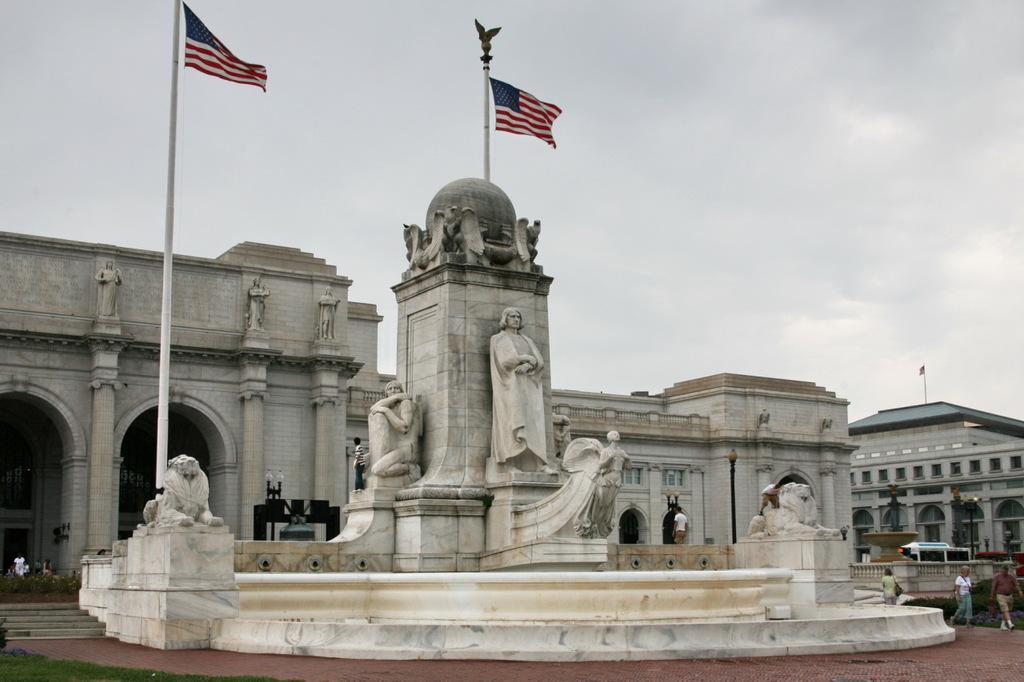In one or two sentences, can you explain what this image depicts? In this picture we can see buildings here, on the right side there are two persons walking, we can see statues here, there are two flags here, there is sky at the top of the picture, there is a pole and light here, we can also see flag post here, at the left bottom we can see grass. 